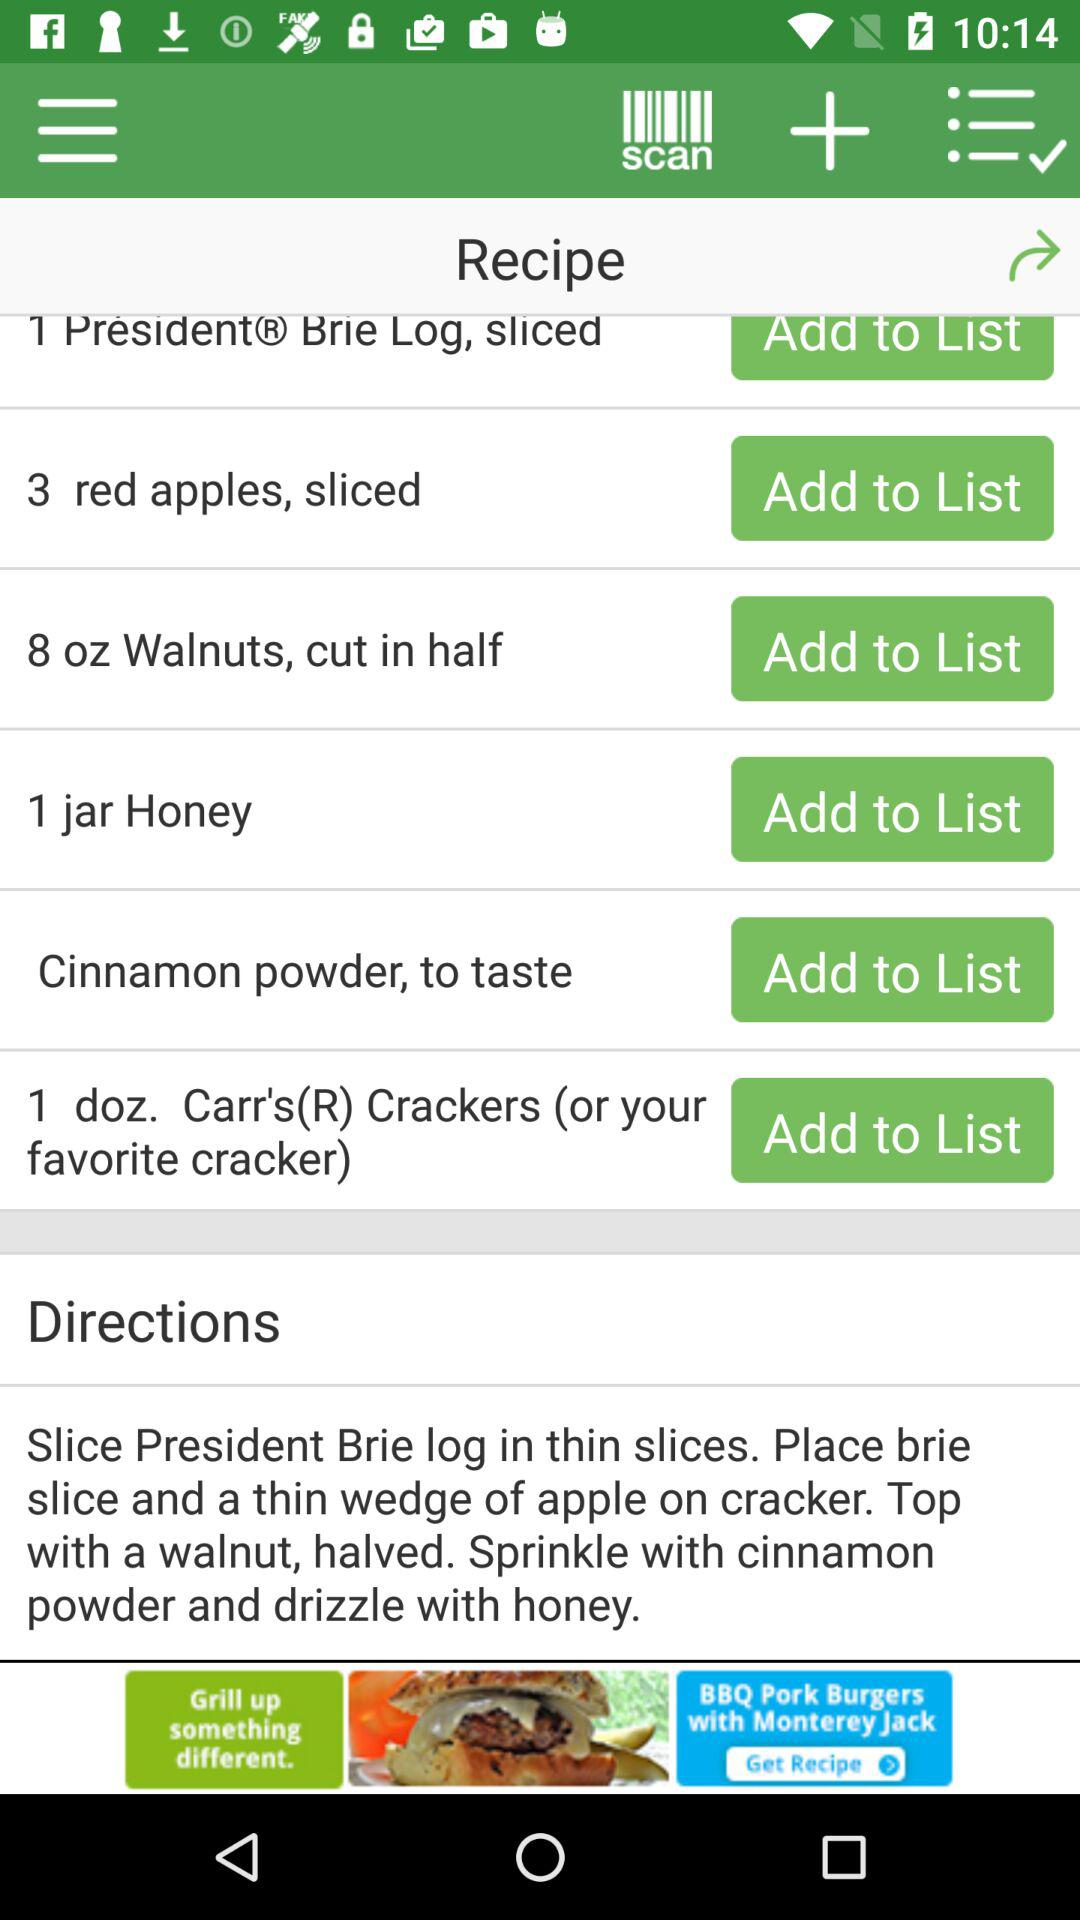How much honey is needed? There is 1 jar of honey needed. 